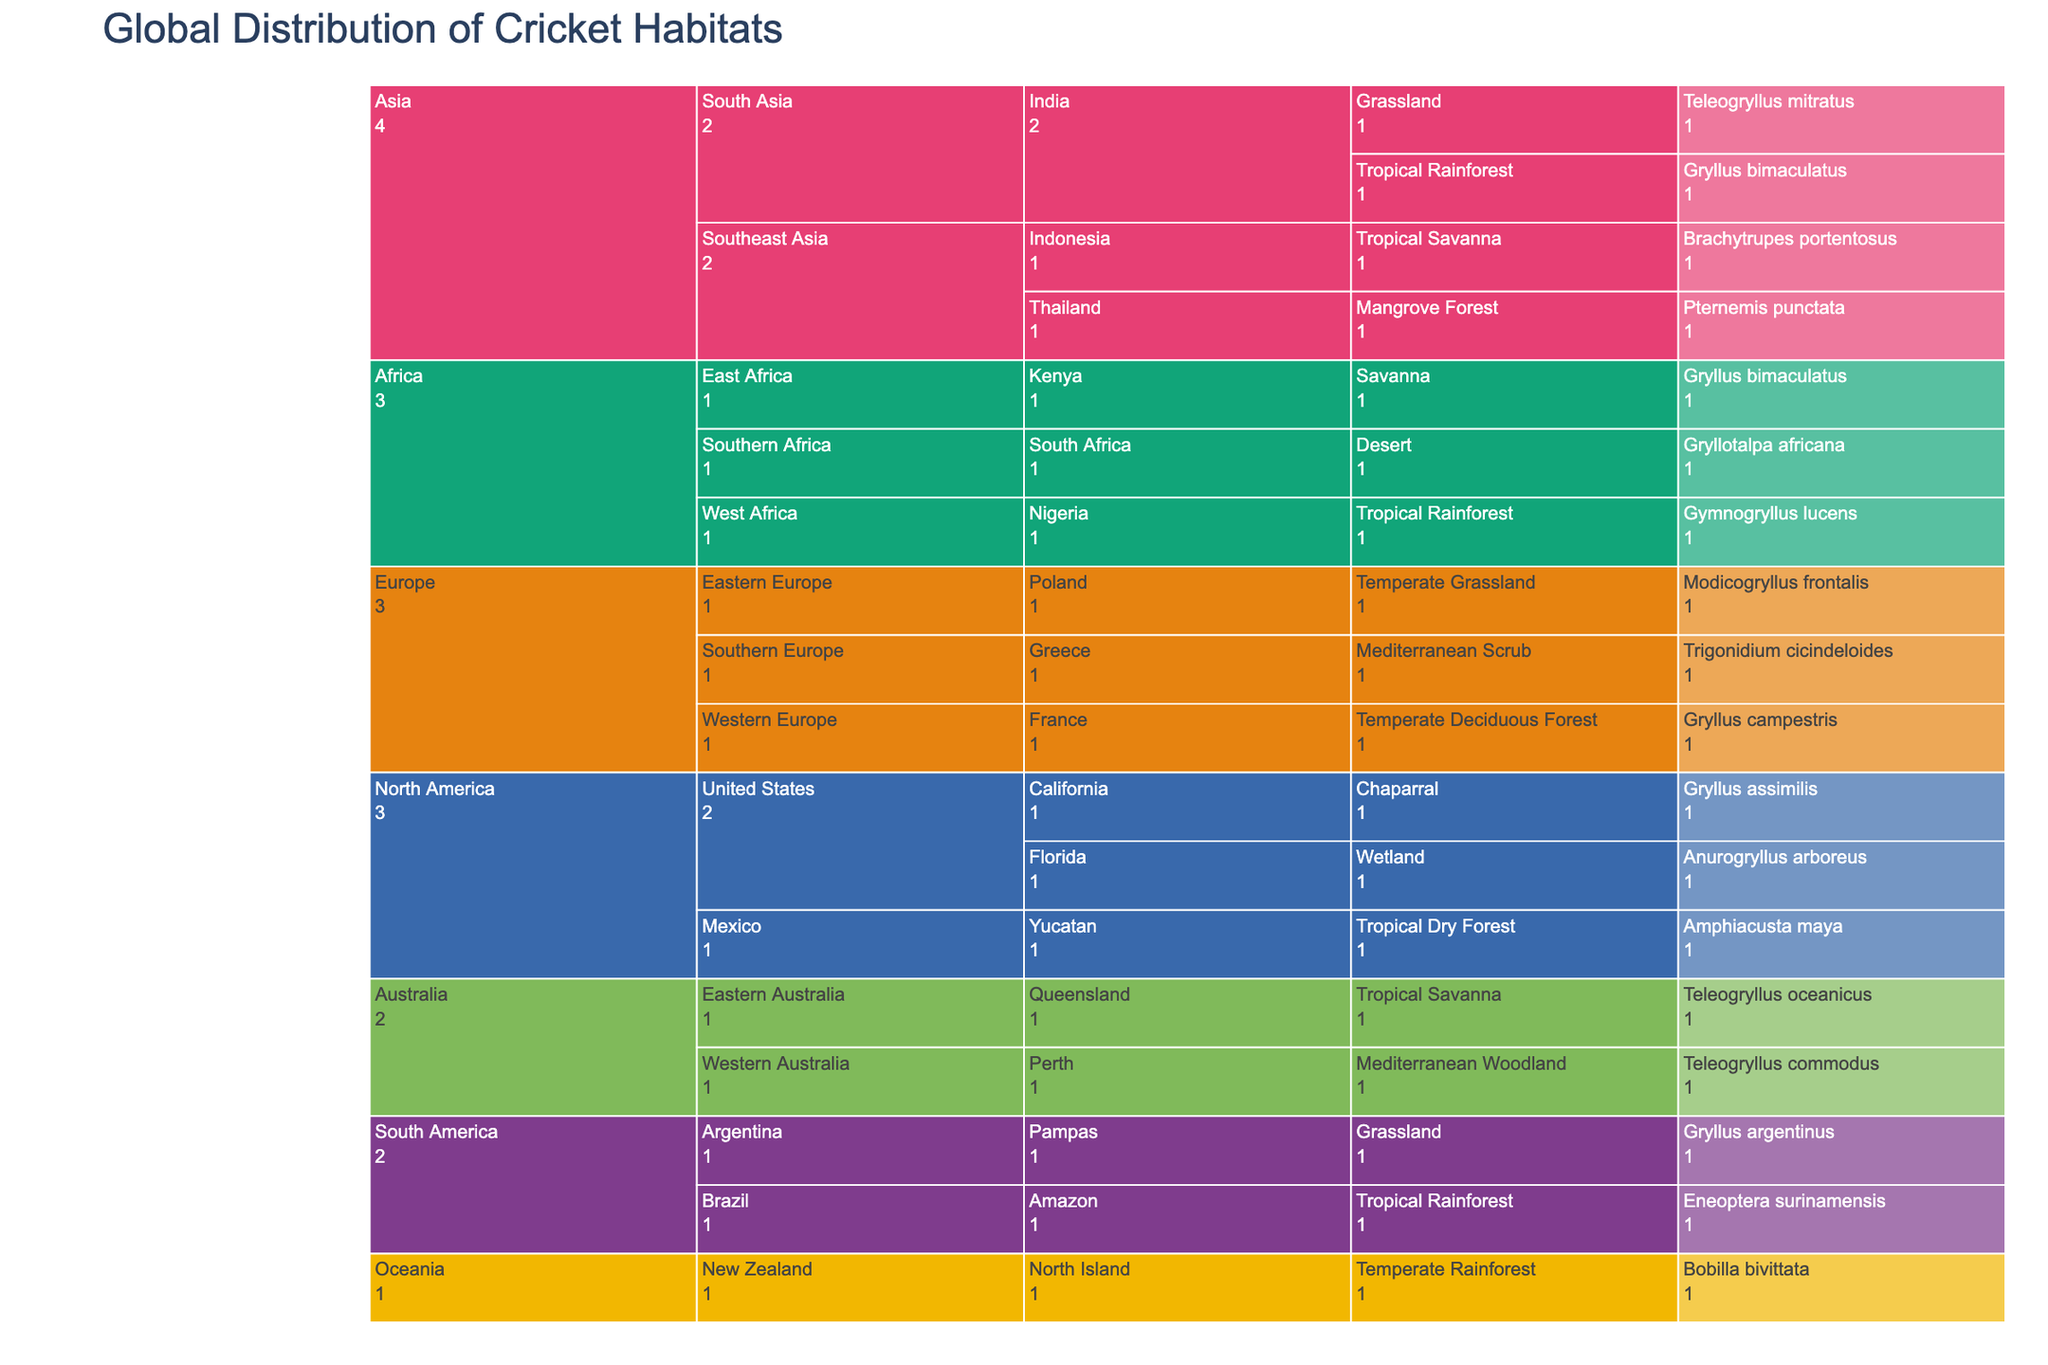What's the title of the figure? The title of the figure is typically displayed at the top of the chart. Here, it reads 'Global Distribution of Cricket Habitats'.
Answer: Global Distribution of Cricket Habitats Which continent has the most diverse cricket ecosystems? To determine this, look at the icicle chart at the 'Continent' level and note the number of subdivisions under each. The continent with the most subdivisions has the most diverse cricket ecosystems.
Answer: Asia How many cricket species are found in Australia? Look at the part of the icicle chart that corresponds to Australia, and count the final segments, which represent the cricket species.
Answer: 2 Which country in Africa has crickets in a Desert ecosystem? Navigate through the icicle chart to Africa, and then to the list of countries. Identify the one with the 'Desert' ecosystem indicated.
Answer: South Africa Compare the number of cricket species in Tropical Rainforest and Grassland ecosystems in South America. Navigate through the continents to South America. Check the number of cricket species listed under 'Amazon' for Tropical Rainforest and 'Pampas' for Grassland. Compare these values.
Answer: Tropical Rainforest: 1, Grassland: 1 What cricket species is found in the Mangrove Forest ecosystem in Asia? Navigate to Asia, then to Southeast Asia, and within that region, find the country and ecosystem, which is Mangrove Forest, and identify the cricket species listed.
Answer: Pternemis punctata Which continent has crickets in the most varying types of ecosystems? Examine the continent labeling and tally the different types of ecosystems under each continent. The one with the highest count of unique ecosystems has the most variety.
Answer: Asia How many cricket species are listed for Eastern Europe? Navigate through Europe to the Eastern Europe region and count the final segments representing the cricket species.
Answer: 1 Which ecosystem hosts the highest number of cricket species across all continents? Visually scan the icicle chart for each ecosystem and tally the cricket species. The ecosystem with the most overlapping segments hosts the highest number of species.
Answer: Tropical Rainforest Which country in North America has cricket species in both Chaparral and Wetland ecosystems? Focus on North America and then examine the countries. Check which country lists cricket species in both Chaparral and Wetland ecosystems.
Answer: United States 